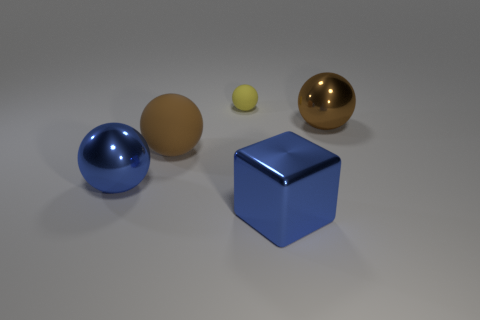Add 2 big things. How many objects exist? 7 Subtract all balls. How many objects are left? 1 Add 1 large brown rubber objects. How many large brown rubber objects are left? 2 Add 3 large gray blocks. How many large gray blocks exist? 3 Subtract 0 cyan cylinders. How many objects are left? 5 Subtract all large brown matte spheres. Subtract all small yellow spheres. How many objects are left? 3 